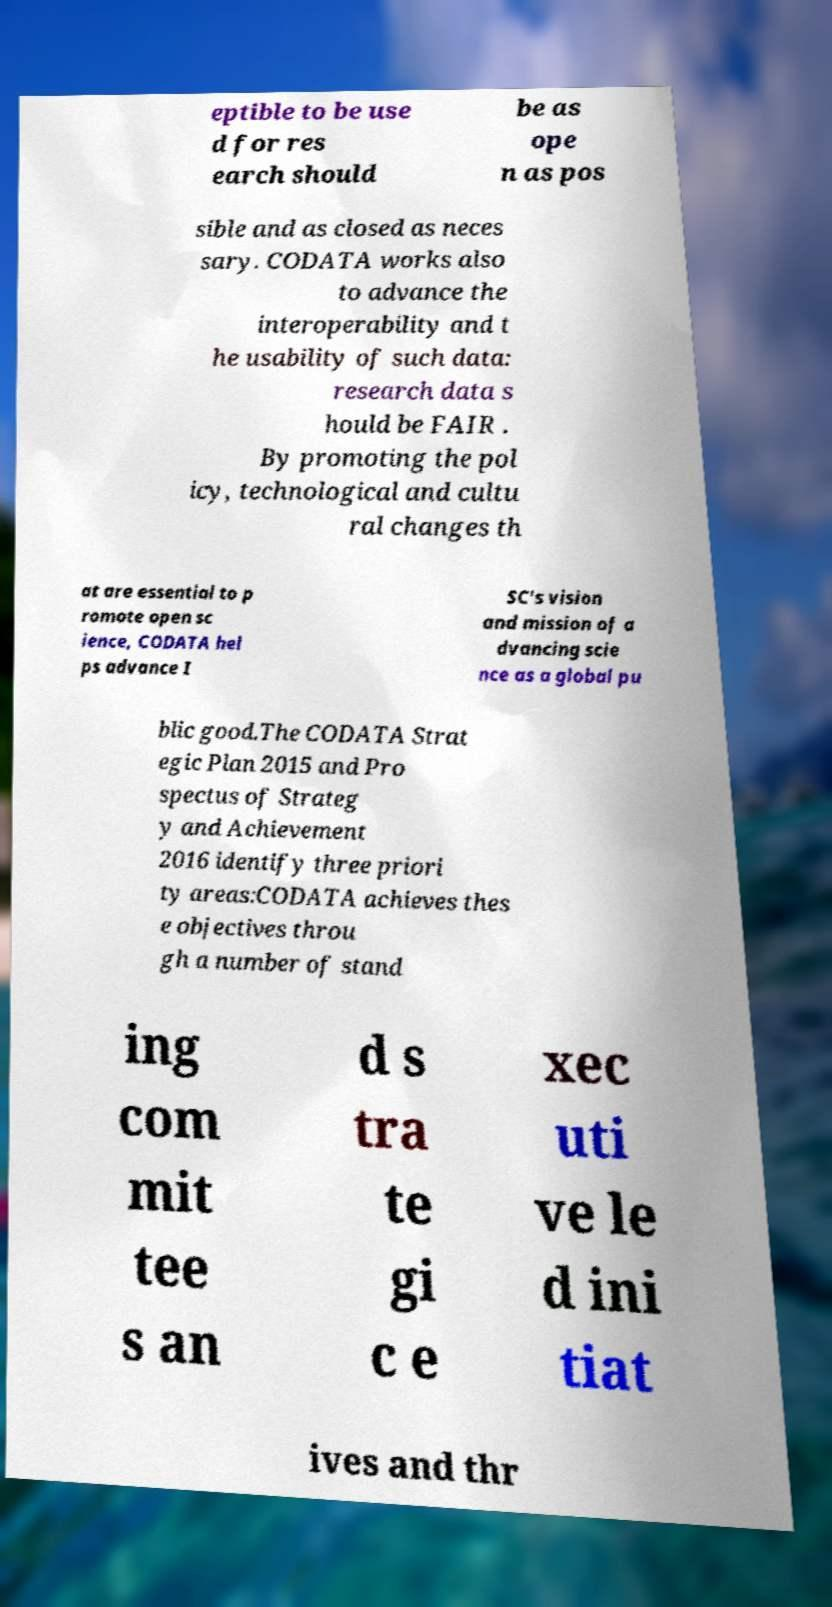Can you accurately transcribe the text from the provided image for me? eptible to be use d for res earch should be as ope n as pos sible and as closed as neces sary. CODATA works also to advance the interoperability and t he usability of such data: research data s hould be FAIR . By promoting the pol icy, technological and cultu ral changes th at are essential to p romote open sc ience, CODATA hel ps advance I SC's vision and mission of a dvancing scie nce as a global pu blic good.The CODATA Strat egic Plan 2015 and Pro spectus of Strateg y and Achievement 2016 identify three priori ty areas:CODATA achieves thes e objectives throu gh a number of stand ing com mit tee s an d s tra te gi c e xec uti ve le d ini tiat ives and thr 